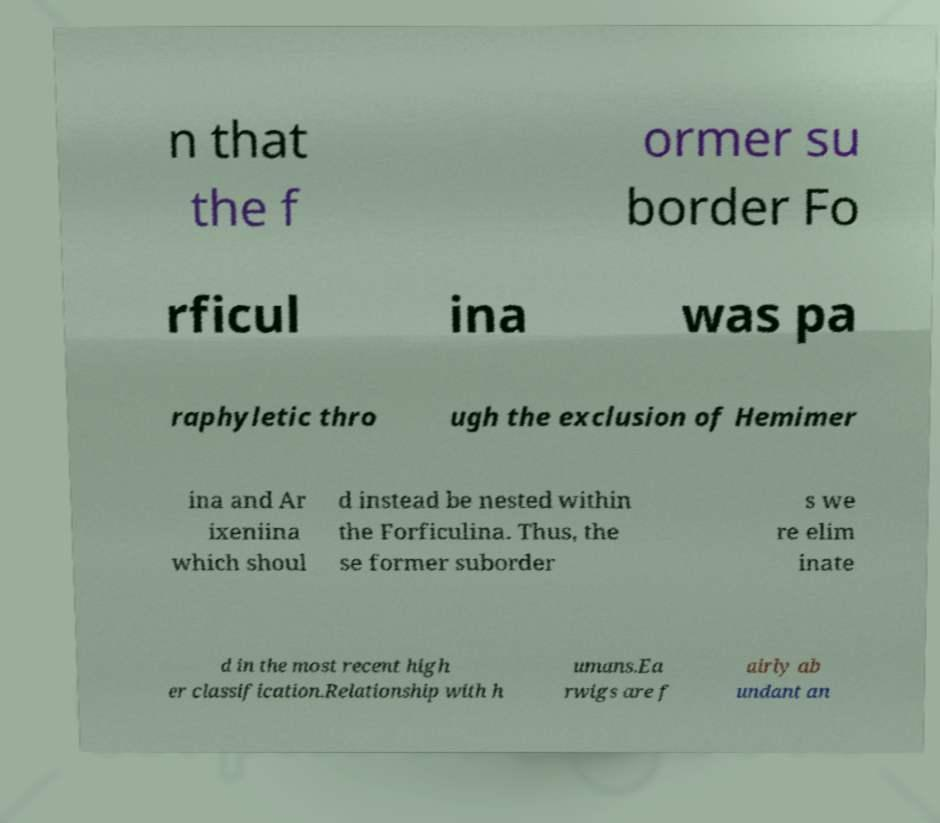Please read and relay the text visible in this image. What does it say? n that the f ormer su border Fo rficul ina was pa raphyletic thro ugh the exclusion of Hemimer ina and Ar ixeniina which shoul d instead be nested within the Forficulina. Thus, the se former suborder s we re elim inate d in the most recent high er classification.Relationship with h umans.Ea rwigs are f airly ab undant an 